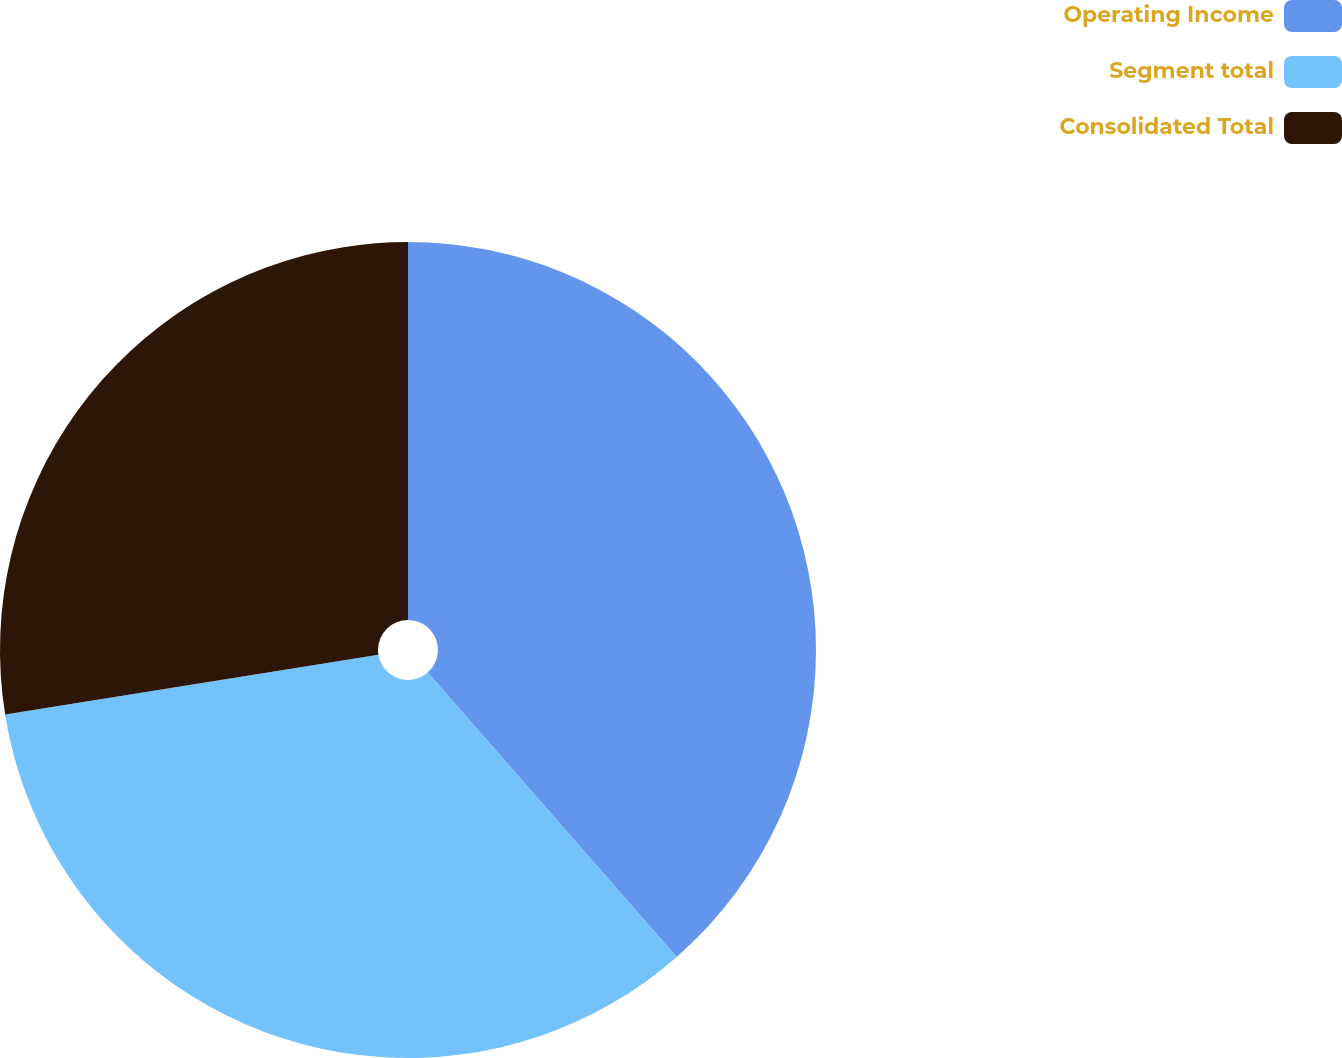Convert chart to OTSL. <chart><loc_0><loc_0><loc_500><loc_500><pie_chart><fcel>Operating Income<fcel>Segment total<fcel>Consolidated Total<nl><fcel>38.56%<fcel>33.91%<fcel>27.53%<nl></chart> 